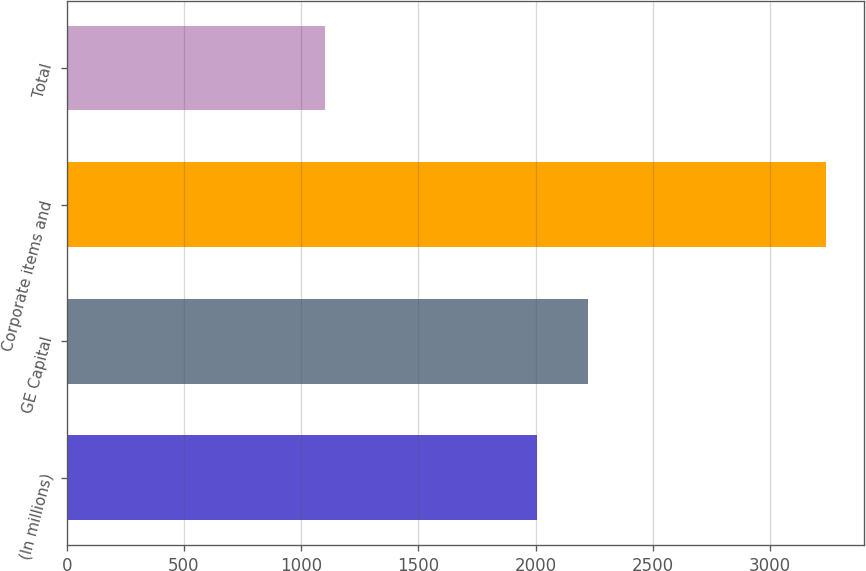Convert chart. <chart><loc_0><loc_0><loc_500><loc_500><bar_chart><fcel>(In millions)<fcel>GE Capital<fcel>Corporate items and<fcel>Total<nl><fcel>2008<fcel>2221.7<fcel>3239<fcel>1102<nl></chart> 